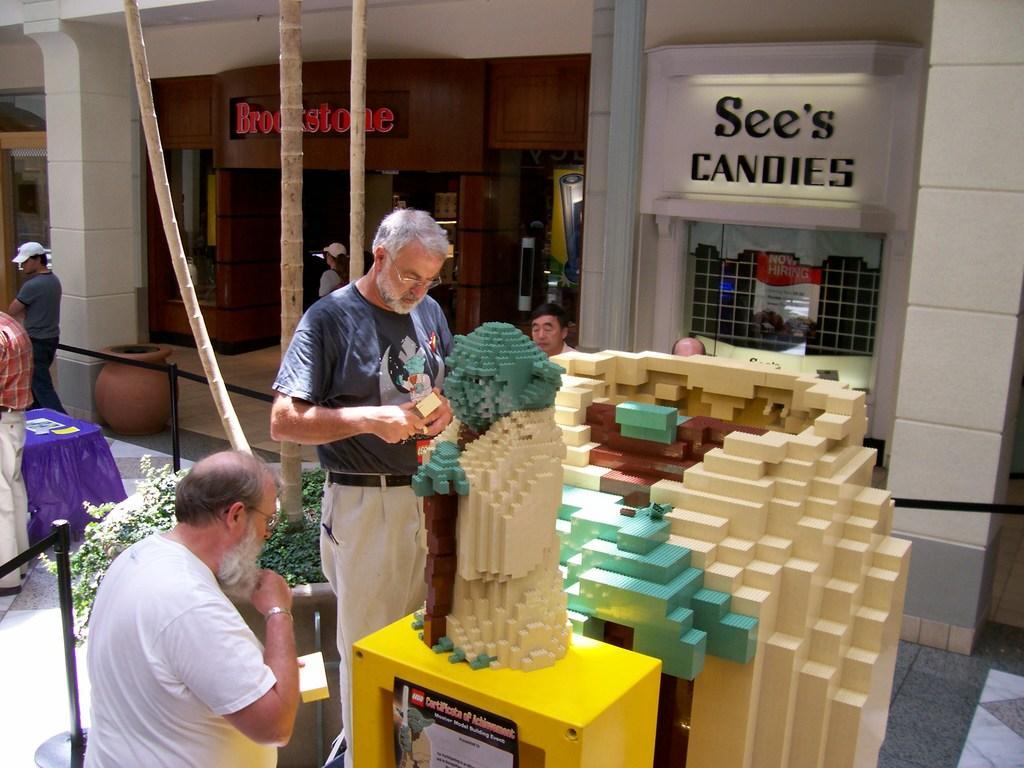Please provide a concise description of this image. In the picture we can see a man standing on the path and construction some puzzle building on the table and beside him we can see a man sitting and behind them we can see a table with blue color cloth on it and two persons standing near it and beside them we can see a building with pillar and a store with a name brook side and beside it we can see another shop with a name see's candies. 